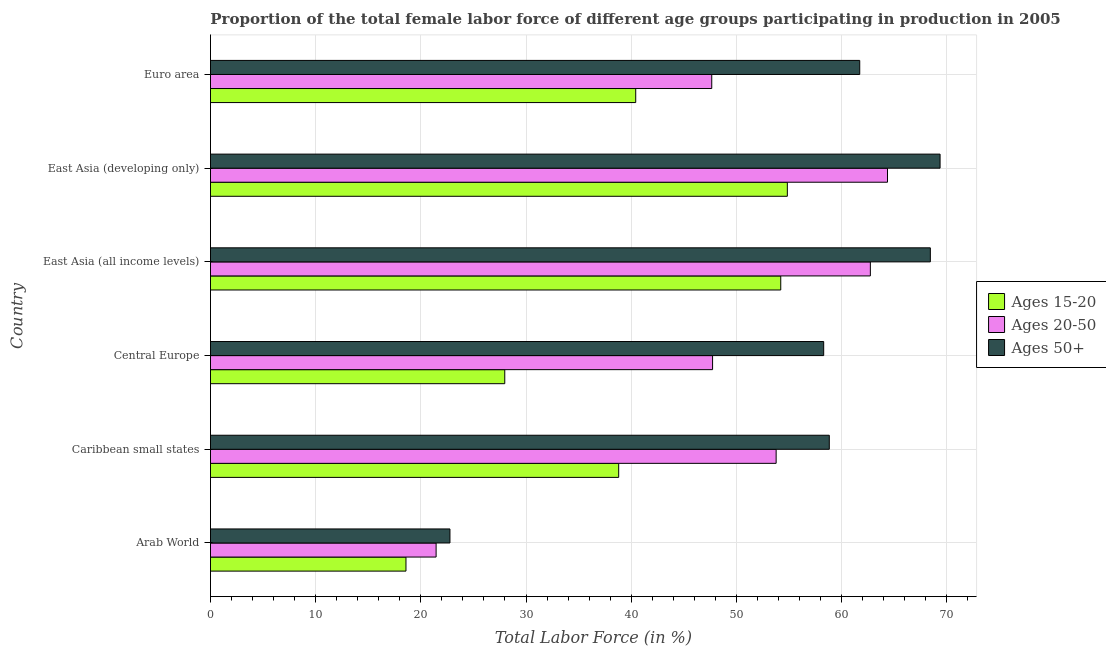How many different coloured bars are there?
Make the answer very short. 3. Are the number of bars per tick equal to the number of legend labels?
Make the answer very short. Yes. What is the label of the 5th group of bars from the top?
Give a very brief answer. Caribbean small states. In how many cases, is the number of bars for a given country not equal to the number of legend labels?
Your response must be concise. 0. What is the percentage of female labor force within the age group 15-20 in Caribbean small states?
Offer a very short reply. 38.81. Across all countries, what is the maximum percentage of female labor force above age 50?
Offer a very short reply. 69.37. Across all countries, what is the minimum percentage of female labor force within the age group 20-50?
Your answer should be compact. 21.45. In which country was the percentage of female labor force above age 50 maximum?
Make the answer very short. East Asia (developing only). In which country was the percentage of female labor force within the age group 15-20 minimum?
Your response must be concise. Arab World. What is the total percentage of female labor force within the age group 15-20 in the graph?
Make the answer very short. 234.87. What is the difference between the percentage of female labor force within the age group 20-50 in Caribbean small states and that in East Asia (all income levels)?
Provide a succinct answer. -8.96. What is the difference between the percentage of female labor force above age 50 in Central Europe and the percentage of female labor force within the age group 15-20 in Euro area?
Keep it short and to the point. 17.87. What is the average percentage of female labor force above age 50 per country?
Give a very brief answer. 56.57. What is the difference between the percentage of female labor force within the age group 20-50 and percentage of female labor force above age 50 in Arab World?
Provide a succinct answer. -1.32. What is the ratio of the percentage of female labor force within the age group 15-20 in Arab World to that in Caribbean small states?
Offer a very short reply. 0.48. Is the difference between the percentage of female labor force above age 50 in Arab World and Euro area greater than the difference between the percentage of female labor force within the age group 20-50 in Arab World and Euro area?
Offer a terse response. No. What is the difference between the highest and the second highest percentage of female labor force within the age group 15-20?
Ensure brevity in your answer.  0.63. What is the difference between the highest and the lowest percentage of female labor force above age 50?
Provide a succinct answer. 46.6. In how many countries, is the percentage of female labor force within the age group 20-50 greater than the average percentage of female labor force within the age group 20-50 taken over all countries?
Give a very brief answer. 3. What does the 3rd bar from the top in Arab World represents?
Your answer should be compact. Ages 15-20. What does the 1st bar from the bottom in Central Europe represents?
Keep it short and to the point. Ages 15-20. How many countries are there in the graph?
Offer a terse response. 6. Are the values on the major ticks of X-axis written in scientific E-notation?
Offer a very short reply. No. Does the graph contain grids?
Give a very brief answer. Yes. Where does the legend appear in the graph?
Your answer should be compact. Center right. How many legend labels are there?
Provide a succinct answer. 3. How are the legend labels stacked?
Your answer should be very brief. Vertical. What is the title of the graph?
Offer a terse response. Proportion of the total female labor force of different age groups participating in production in 2005. Does "Primary" appear as one of the legend labels in the graph?
Your response must be concise. No. What is the label or title of the X-axis?
Your answer should be very brief. Total Labor Force (in %). What is the Total Labor Force (in %) in Ages 15-20 in Arab World?
Ensure brevity in your answer.  18.59. What is the Total Labor Force (in %) of Ages 20-50 in Arab World?
Your answer should be very brief. 21.45. What is the Total Labor Force (in %) in Ages 50+ in Arab World?
Make the answer very short. 22.77. What is the Total Labor Force (in %) in Ages 15-20 in Caribbean small states?
Make the answer very short. 38.81. What is the Total Labor Force (in %) of Ages 20-50 in Caribbean small states?
Your answer should be very brief. 53.78. What is the Total Labor Force (in %) of Ages 50+ in Caribbean small states?
Your answer should be compact. 58.84. What is the Total Labor Force (in %) of Ages 15-20 in Central Europe?
Offer a very short reply. 27.98. What is the Total Labor Force (in %) in Ages 20-50 in Central Europe?
Your response must be concise. 47.74. What is the Total Labor Force (in %) in Ages 50+ in Central Europe?
Ensure brevity in your answer.  58.3. What is the Total Labor Force (in %) in Ages 15-20 in East Asia (all income levels)?
Your answer should be compact. 54.22. What is the Total Labor Force (in %) of Ages 20-50 in East Asia (all income levels)?
Your answer should be very brief. 62.74. What is the Total Labor Force (in %) in Ages 50+ in East Asia (all income levels)?
Offer a very short reply. 68.44. What is the Total Labor Force (in %) in Ages 15-20 in East Asia (developing only)?
Your answer should be very brief. 54.85. What is the Total Labor Force (in %) in Ages 20-50 in East Asia (developing only)?
Give a very brief answer. 64.37. What is the Total Labor Force (in %) of Ages 50+ in East Asia (developing only)?
Give a very brief answer. 69.37. What is the Total Labor Force (in %) of Ages 15-20 in Euro area?
Your response must be concise. 40.43. What is the Total Labor Force (in %) in Ages 20-50 in Euro area?
Your answer should be compact. 47.66. What is the Total Labor Force (in %) of Ages 50+ in Euro area?
Make the answer very short. 61.73. Across all countries, what is the maximum Total Labor Force (in %) in Ages 15-20?
Offer a very short reply. 54.85. Across all countries, what is the maximum Total Labor Force (in %) in Ages 20-50?
Offer a terse response. 64.37. Across all countries, what is the maximum Total Labor Force (in %) in Ages 50+?
Ensure brevity in your answer.  69.37. Across all countries, what is the minimum Total Labor Force (in %) in Ages 15-20?
Offer a terse response. 18.59. Across all countries, what is the minimum Total Labor Force (in %) in Ages 20-50?
Keep it short and to the point. 21.45. Across all countries, what is the minimum Total Labor Force (in %) of Ages 50+?
Give a very brief answer. 22.77. What is the total Total Labor Force (in %) of Ages 15-20 in the graph?
Ensure brevity in your answer.  234.87. What is the total Total Labor Force (in %) in Ages 20-50 in the graph?
Give a very brief answer. 297.74. What is the total Total Labor Force (in %) of Ages 50+ in the graph?
Give a very brief answer. 339.44. What is the difference between the Total Labor Force (in %) of Ages 15-20 in Arab World and that in Caribbean small states?
Ensure brevity in your answer.  -20.22. What is the difference between the Total Labor Force (in %) in Ages 20-50 in Arab World and that in Caribbean small states?
Give a very brief answer. -32.33. What is the difference between the Total Labor Force (in %) of Ages 50+ in Arab World and that in Caribbean small states?
Provide a succinct answer. -36.07. What is the difference between the Total Labor Force (in %) of Ages 15-20 in Arab World and that in Central Europe?
Make the answer very short. -9.39. What is the difference between the Total Labor Force (in %) of Ages 20-50 in Arab World and that in Central Europe?
Offer a terse response. -26.29. What is the difference between the Total Labor Force (in %) of Ages 50+ in Arab World and that in Central Europe?
Give a very brief answer. -35.53. What is the difference between the Total Labor Force (in %) of Ages 15-20 in Arab World and that in East Asia (all income levels)?
Provide a succinct answer. -35.63. What is the difference between the Total Labor Force (in %) of Ages 20-50 in Arab World and that in East Asia (all income levels)?
Your answer should be compact. -41.29. What is the difference between the Total Labor Force (in %) in Ages 50+ in Arab World and that in East Asia (all income levels)?
Ensure brevity in your answer.  -45.67. What is the difference between the Total Labor Force (in %) of Ages 15-20 in Arab World and that in East Asia (developing only)?
Offer a very short reply. -36.26. What is the difference between the Total Labor Force (in %) in Ages 20-50 in Arab World and that in East Asia (developing only)?
Offer a terse response. -42.92. What is the difference between the Total Labor Force (in %) in Ages 50+ in Arab World and that in East Asia (developing only)?
Your answer should be compact. -46.6. What is the difference between the Total Labor Force (in %) in Ages 15-20 in Arab World and that in Euro area?
Provide a succinct answer. -21.84. What is the difference between the Total Labor Force (in %) in Ages 20-50 in Arab World and that in Euro area?
Provide a succinct answer. -26.21. What is the difference between the Total Labor Force (in %) in Ages 50+ in Arab World and that in Euro area?
Provide a short and direct response. -38.96. What is the difference between the Total Labor Force (in %) of Ages 15-20 in Caribbean small states and that in Central Europe?
Keep it short and to the point. 10.83. What is the difference between the Total Labor Force (in %) in Ages 20-50 in Caribbean small states and that in Central Europe?
Offer a very short reply. 6.04. What is the difference between the Total Labor Force (in %) of Ages 50+ in Caribbean small states and that in Central Europe?
Provide a succinct answer. 0.53. What is the difference between the Total Labor Force (in %) in Ages 15-20 in Caribbean small states and that in East Asia (all income levels)?
Make the answer very short. -15.41. What is the difference between the Total Labor Force (in %) in Ages 20-50 in Caribbean small states and that in East Asia (all income levels)?
Ensure brevity in your answer.  -8.96. What is the difference between the Total Labor Force (in %) of Ages 50+ in Caribbean small states and that in East Asia (all income levels)?
Your response must be concise. -9.61. What is the difference between the Total Labor Force (in %) in Ages 15-20 in Caribbean small states and that in East Asia (developing only)?
Ensure brevity in your answer.  -16.04. What is the difference between the Total Labor Force (in %) in Ages 20-50 in Caribbean small states and that in East Asia (developing only)?
Keep it short and to the point. -10.59. What is the difference between the Total Labor Force (in %) of Ages 50+ in Caribbean small states and that in East Asia (developing only)?
Your answer should be very brief. -10.53. What is the difference between the Total Labor Force (in %) of Ages 15-20 in Caribbean small states and that in Euro area?
Keep it short and to the point. -1.62. What is the difference between the Total Labor Force (in %) in Ages 20-50 in Caribbean small states and that in Euro area?
Give a very brief answer. 6.12. What is the difference between the Total Labor Force (in %) in Ages 50+ in Caribbean small states and that in Euro area?
Your answer should be very brief. -2.89. What is the difference between the Total Labor Force (in %) of Ages 15-20 in Central Europe and that in East Asia (all income levels)?
Make the answer very short. -26.24. What is the difference between the Total Labor Force (in %) of Ages 20-50 in Central Europe and that in East Asia (all income levels)?
Offer a very short reply. -15. What is the difference between the Total Labor Force (in %) of Ages 50+ in Central Europe and that in East Asia (all income levels)?
Your answer should be compact. -10.14. What is the difference between the Total Labor Force (in %) in Ages 15-20 in Central Europe and that in East Asia (developing only)?
Provide a short and direct response. -26.87. What is the difference between the Total Labor Force (in %) of Ages 20-50 in Central Europe and that in East Asia (developing only)?
Offer a terse response. -16.63. What is the difference between the Total Labor Force (in %) in Ages 50+ in Central Europe and that in East Asia (developing only)?
Give a very brief answer. -11.07. What is the difference between the Total Labor Force (in %) of Ages 15-20 in Central Europe and that in Euro area?
Provide a succinct answer. -12.45. What is the difference between the Total Labor Force (in %) of Ages 20-50 in Central Europe and that in Euro area?
Your response must be concise. 0.08. What is the difference between the Total Labor Force (in %) of Ages 50+ in Central Europe and that in Euro area?
Offer a very short reply. -3.43. What is the difference between the Total Labor Force (in %) in Ages 15-20 in East Asia (all income levels) and that in East Asia (developing only)?
Your answer should be very brief. -0.63. What is the difference between the Total Labor Force (in %) of Ages 20-50 in East Asia (all income levels) and that in East Asia (developing only)?
Your answer should be compact. -1.63. What is the difference between the Total Labor Force (in %) of Ages 50+ in East Asia (all income levels) and that in East Asia (developing only)?
Give a very brief answer. -0.93. What is the difference between the Total Labor Force (in %) of Ages 15-20 in East Asia (all income levels) and that in Euro area?
Your response must be concise. 13.79. What is the difference between the Total Labor Force (in %) in Ages 20-50 in East Asia (all income levels) and that in Euro area?
Offer a terse response. 15.08. What is the difference between the Total Labor Force (in %) in Ages 50+ in East Asia (all income levels) and that in Euro area?
Give a very brief answer. 6.71. What is the difference between the Total Labor Force (in %) in Ages 15-20 in East Asia (developing only) and that in Euro area?
Offer a terse response. 14.42. What is the difference between the Total Labor Force (in %) in Ages 20-50 in East Asia (developing only) and that in Euro area?
Keep it short and to the point. 16.71. What is the difference between the Total Labor Force (in %) in Ages 50+ in East Asia (developing only) and that in Euro area?
Offer a very short reply. 7.64. What is the difference between the Total Labor Force (in %) in Ages 15-20 in Arab World and the Total Labor Force (in %) in Ages 20-50 in Caribbean small states?
Provide a short and direct response. -35.19. What is the difference between the Total Labor Force (in %) of Ages 15-20 in Arab World and the Total Labor Force (in %) of Ages 50+ in Caribbean small states?
Your answer should be very brief. -40.25. What is the difference between the Total Labor Force (in %) of Ages 20-50 in Arab World and the Total Labor Force (in %) of Ages 50+ in Caribbean small states?
Your answer should be compact. -37.38. What is the difference between the Total Labor Force (in %) in Ages 15-20 in Arab World and the Total Labor Force (in %) in Ages 20-50 in Central Europe?
Your answer should be compact. -29.15. What is the difference between the Total Labor Force (in %) of Ages 15-20 in Arab World and the Total Labor Force (in %) of Ages 50+ in Central Europe?
Provide a succinct answer. -39.72. What is the difference between the Total Labor Force (in %) of Ages 20-50 in Arab World and the Total Labor Force (in %) of Ages 50+ in Central Europe?
Your answer should be very brief. -36.85. What is the difference between the Total Labor Force (in %) in Ages 15-20 in Arab World and the Total Labor Force (in %) in Ages 20-50 in East Asia (all income levels)?
Make the answer very short. -44.15. What is the difference between the Total Labor Force (in %) of Ages 15-20 in Arab World and the Total Labor Force (in %) of Ages 50+ in East Asia (all income levels)?
Your answer should be very brief. -49.85. What is the difference between the Total Labor Force (in %) in Ages 20-50 in Arab World and the Total Labor Force (in %) in Ages 50+ in East Asia (all income levels)?
Your response must be concise. -46.99. What is the difference between the Total Labor Force (in %) in Ages 15-20 in Arab World and the Total Labor Force (in %) in Ages 20-50 in East Asia (developing only)?
Your answer should be very brief. -45.78. What is the difference between the Total Labor Force (in %) in Ages 15-20 in Arab World and the Total Labor Force (in %) in Ages 50+ in East Asia (developing only)?
Your response must be concise. -50.78. What is the difference between the Total Labor Force (in %) of Ages 20-50 in Arab World and the Total Labor Force (in %) of Ages 50+ in East Asia (developing only)?
Ensure brevity in your answer.  -47.91. What is the difference between the Total Labor Force (in %) of Ages 15-20 in Arab World and the Total Labor Force (in %) of Ages 20-50 in Euro area?
Your answer should be very brief. -29.07. What is the difference between the Total Labor Force (in %) in Ages 15-20 in Arab World and the Total Labor Force (in %) in Ages 50+ in Euro area?
Provide a short and direct response. -43.14. What is the difference between the Total Labor Force (in %) in Ages 20-50 in Arab World and the Total Labor Force (in %) in Ages 50+ in Euro area?
Ensure brevity in your answer.  -40.28. What is the difference between the Total Labor Force (in %) of Ages 15-20 in Caribbean small states and the Total Labor Force (in %) of Ages 20-50 in Central Europe?
Offer a very short reply. -8.93. What is the difference between the Total Labor Force (in %) in Ages 15-20 in Caribbean small states and the Total Labor Force (in %) in Ages 50+ in Central Europe?
Provide a short and direct response. -19.49. What is the difference between the Total Labor Force (in %) in Ages 20-50 in Caribbean small states and the Total Labor Force (in %) in Ages 50+ in Central Europe?
Your answer should be compact. -4.52. What is the difference between the Total Labor Force (in %) of Ages 15-20 in Caribbean small states and the Total Labor Force (in %) of Ages 20-50 in East Asia (all income levels)?
Provide a short and direct response. -23.93. What is the difference between the Total Labor Force (in %) of Ages 15-20 in Caribbean small states and the Total Labor Force (in %) of Ages 50+ in East Asia (all income levels)?
Ensure brevity in your answer.  -29.63. What is the difference between the Total Labor Force (in %) of Ages 20-50 in Caribbean small states and the Total Labor Force (in %) of Ages 50+ in East Asia (all income levels)?
Your answer should be very brief. -14.66. What is the difference between the Total Labor Force (in %) in Ages 15-20 in Caribbean small states and the Total Labor Force (in %) in Ages 20-50 in East Asia (developing only)?
Your response must be concise. -25.56. What is the difference between the Total Labor Force (in %) in Ages 15-20 in Caribbean small states and the Total Labor Force (in %) in Ages 50+ in East Asia (developing only)?
Make the answer very short. -30.56. What is the difference between the Total Labor Force (in %) of Ages 20-50 in Caribbean small states and the Total Labor Force (in %) of Ages 50+ in East Asia (developing only)?
Provide a short and direct response. -15.59. What is the difference between the Total Labor Force (in %) of Ages 15-20 in Caribbean small states and the Total Labor Force (in %) of Ages 20-50 in Euro area?
Keep it short and to the point. -8.85. What is the difference between the Total Labor Force (in %) of Ages 15-20 in Caribbean small states and the Total Labor Force (in %) of Ages 50+ in Euro area?
Give a very brief answer. -22.92. What is the difference between the Total Labor Force (in %) in Ages 20-50 in Caribbean small states and the Total Labor Force (in %) in Ages 50+ in Euro area?
Offer a terse response. -7.95. What is the difference between the Total Labor Force (in %) of Ages 15-20 in Central Europe and the Total Labor Force (in %) of Ages 20-50 in East Asia (all income levels)?
Keep it short and to the point. -34.76. What is the difference between the Total Labor Force (in %) in Ages 15-20 in Central Europe and the Total Labor Force (in %) in Ages 50+ in East Asia (all income levels)?
Make the answer very short. -40.46. What is the difference between the Total Labor Force (in %) in Ages 20-50 in Central Europe and the Total Labor Force (in %) in Ages 50+ in East Asia (all income levels)?
Your answer should be very brief. -20.7. What is the difference between the Total Labor Force (in %) of Ages 15-20 in Central Europe and the Total Labor Force (in %) of Ages 20-50 in East Asia (developing only)?
Provide a succinct answer. -36.39. What is the difference between the Total Labor Force (in %) in Ages 15-20 in Central Europe and the Total Labor Force (in %) in Ages 50+ in East Asia (developing only)?
Provide a short and direct response. -41.39. What is the difference between the Total Labor Force (in %) in Ages 20-50 in Central Europe and the Total Labor Force (in %) in Ages 50+ in East Asia (developing only)?
Your answer should be compact. -21.63. What is the difference between the Total Labor Force (in %) in Ages 15-20 in Central Europe and the Total Labor Force (in %) in Ages 20-50 in Euro area?
Provide a short and direct response. -19.68. What is the difference between the Total Labor Force (in %) in Ages 15-20 in Central Europe and the Total Labor Force (in %) in Ages 50+ in Euro area?
Provide a short and direct response. -33.75. What is the difference between the Total Labor Force (in %) of Ages 20-50 in Central Europe and the Total Labor Force (in %) of Ages 50+ in Euro area?
Make the answer very short. -13.99. What is the difference between the Total Labor Force (in %) of Ages 15-20 in East Asia (all income levels) and the Total Labor Force (in %) of Ages 20-50 in East Asia (developing only)?
Your answer should be very brief. -10.15. What is the difference between the Total Labor Force (in %) of Ages 15-20 in East Asia (all income levels) and the Total Labor Force (in %) of Ages 50+ in East Asia (developing only)?
Give a very brief answer. -15.15. What is the difference between the Total Labor Force (in %) in Ages 20-50 in East Asia (all income levels) and the Total Labor Force (in %) in Ages 50+ in East Asia (developing only)?
Keep it short and to the point. -6.63. What is the difference between the Total Labor Force (in %) in Ages 15-20 in East Asia (all income levels) and the Total Labor Force (in %) in Ages 20-50 in Euro area?
Give a very brief answer. 6.56. What is the difference between the Total Labor Force (in %) of Ages 15-20 in East Asia (all income levels) and the Total Labor Force (in %) of Ages 50+ in Euro area?
Offer a terse response. -7.51. What is the difference between the Total Labor Force (in %) in Ages 20-50 in East Asia (all income levels) and the Total Labor Force (in %) in Ages 50+ in Euro area?
Offer a terse response. 1.01. What is the difference between the Total Labor Force (in %) of Ages 15-20 in East Asia (developing only) and the Total Labor Force (in %) of Ages 20-50 in Euro area?
Your answer should be very brief. 7.19. What is the difference between the Total Labor Force (in %) of Ages 15-20 in East Asia (developing only) and the Total Labor Force (in %) of Ages 50+ in Euro area?
Give a very brief answer. -6.88. What is the difference between the Total Labor Force (in %) in Ages 20-50 in East Asia (developing only) and the Total Labor Force (in %) in Ages 50+ in Euro area?
Keep it short and to the point. 2.64. What is the average Total Labor Force (in %) in Ages 15-20 per country?
Your response must be concise. 39.15. What is the average Total Labor Force (in %) of Ages 20-50 per country?
Your answer should be compact. 49.62. What is the average Total Labor Force (in %) of Ages 50+ per country?
Keep it short and to the point. 56.57. What is the difference between the Total Labor Force (in %) of Ages 15-20 and Total Labor Force (in %) of Ages 20-50 in Arab World?
Your response must be concise. -2.87. What is the difference between the Total Labor Force (in %) of Ages 15-20 and Total Labor Force (in %) of Ages 50+ in Arab World?
Your answer should be compact. -4.18. What is the difference between the Total Labor Force (in %) of Ages 20-50 and Total Labor Force (in %) of Ages 50+ in Arab World?
Make the answer very short. -1.32. What is the difference between the Total Labor Force (in %) in Ages 15-20 and Total Labor Force (in %) in Ages 20-50 in Caribbean small states?
Your answer should be very brief. -14.97. What is the difference between the Total Labor Force (in %) of Ages 15-20 and Total Labor Force (in %) of Ages 50+ in Caribbean small states?
Make the answer very short. -20.02. What is the difference between the Total Labor Force (in %) in Ages 20-50 and Total Labor Force (in %) in Ages 50+ in Caribbean small states?
Ensure brevity in your answer.  -5.05. What is the difference between the Total Labor Force (in %) of Ages 15-20 and Total Labor Force (in %) of Ages 20-50 in Central Europe?
Offer a very short reply. -19.76. What is the difference between the Total Labor Force (in %) in Ages 15-20 and Total Labor Force (in %) in Ages 50+ in Central Europe?
Offer a very short reply. -30.32. What is the difference between the Total Labor Force (in %) in Ages 20-50 and Total Labor Force (in %) in Ages 50+ in Central Europe?
Give a very brief answer. -10.56. What is the difference between the Total Labor Force (in %) of Ages 15-20 and Total Labor Force (in %) of Ages 20-50 in East Asia (all income levels)?
Ensure brevity in your answer.  -8.52. What is the difference between the Total Labor Force (in %) of Ages 15-20 and Total Labor Force (in %) of Ages 50+ in East Asia (all income levels)?
Give a very brief answer. -14.22. What is the difference between the Total Labor Force (in %) in Ages 20-50 and Total Labor Force (in %) in Ages 50+ in East Asia (all income levels)?
Make the answer very short. -5.7. What is the difference between the Total Labor Force (in %) in Ages 15-20 and Total Labor Force (in %) in Ages 20-50 in East Asia (developing only)?
Your answer should be compact. -9.52. What is the difference between the Total Labor Force (in %) of Ages 15-20 and Total Labor Force (in %) of Ages 50+ in East Asia (developing only)?
Offer a very short reply. -14.52. What is the difference between the Total Labor Force (in %) in Ages 20-50 and Total Labor Force (in %) in Ages 50+ in East Asia (developing only)?
Ensure brevity in your answer.  -5. What is the difference between the Total Labor Force (in %) in Ages 15-20 and Total Labor Force (in %) in Ages 20-50 in Euro area?
Give a very brief answer. -7.23. What is the difference between the Total Labor Force (in %) in Ages 15-20 and Total Labor Force (in %) in Ages 50+ in Euro area?
Your response must be concise. -21.3. What is the difference between the Total Labor Force (in %) of Ages 20-50 and Total Labor Force (in %) of Ages 50+ in Euro area?
Offer a very short reply. -14.07. What is the ratio of the Total Labor Force (in %) of Ages 15-20 in Arab World to that in Caribbean small states?
Provide a succinct answer. 0.48. What is the ratio of the Total Labor Force (in %) of Ages 20-50 in Arab World to that in Caribbean small states?
Your response must be concise. 0.4. What is the ratio of the Total Labor Force (in %) in Ages 50+ in Arab World to that in Caribbean small states?
Make the answer very short. 0.39. What is the ratio of the Total Labor Force (in %) of Ages 15-20 in Arab World to that in Central Europe?
Keep it short and to the point. 0.66. What is the ratio of the Total Labor Force (in %) of Ages 20-50 in Arab World to that in Central Europe?
Offer a very short reply. 0.45. What is the ratio of the Total Labor Force (in %) of Ages 50+ in Arab World to that in Central Europe?
Provide a short and direct response. 0.39. What is the ratio of the Total Labor Force (in %) of Ages 15-20 in Arab World to that in East Asia (all income levels)?
Offer a very short reply. 0.34. What is the ratio of the Total Labor Force (in %) of Ages 20-50 in Arab World to that in East Asia (all income levels)?
Your answer should be very brief. 0.34. What is the ratio of the Total Labor Force (in %) in Ages 50+ in Arab World to that in East Asia (all income levels)?
Your answer should be compact. 0.33. What is the ratio of the Total Labor Force (in %) of Ages 15-20 in Arab World to that in East Asia (developing only)?
Offer a terse response. 0.34. What is the ratio of the Total Labor Force (in %) of Ages 50+ in Arab World to that in East Asia (developing only)?
Give a very brief answer. 0.33. What is the ratio of the Total Labor Force (in %) of Ages 15-20 in Arab World to that in Euro area?
Offer a very short reply. 0.46. What is the ratio of the Total Labor Force (in %) in Ages 20-50 in Arab World to that in Euro area?
Make the answer very short. 0.45. What is the ratio of the Total Labor Force (in %) of Ages 50+ in Arab World to that in Euro area?
Provide a short and direct response. 0.37. What is the ratio of the Total Labor Force (in %) in Ages 15-20 in Caribbean small states to that in Central Europe?
Your answer should be compact. 1.39. What is the ratio of the Total Labor Force (in %) of Ages 20-50 in Caribbean small states to that in Central Europe?
Your answer should be very brief. 1.13. What is the ratio of the Total Labor Force (in %) of Ages 50+ in Caribbean small states to that in Central Europe?
Your answer should be very brief. 1.01. What is the ratio of the Total Labor Force (in %) of Ages 15-20 in Caribbean small states to that in East Asia (all income levels)?
Your answer should be compact. 0.72. What is the ratio of the Total Labor Force (in %) of Ages 20-50 in Caribbean small states to that in East Asia (all income levels)?
Your answer should be compact. 0.86. What is the ratio of the Total Labor Force (in %) of Ages 50+ in Caribbean small states to that in East Asia (all income levels)?
Give a very brief answer. 0.86. What is the ratio of the Total Labor Force (in %) of Ages 15-20 in Caribbean small states to that in East Asia (developing only)?
Make the answer very short. 0.71. What is the ratio of the Total Labor Force (in %) in Ages 20-50 in Caribbean small states to that in East Asia (developing only)?
Your response must be concise. 0.84. What is the ratio of the Total Labor Force (in %) in Ages 50+ in Caribbean small states to that in East Asia (developing only)?
Your response must be concise. 0.85. What is the ratio of the Total Labor Force (in %) of Ages 15-20 in Caribbean small states to that in Euro area?
Offer a very short reply. 0.96. What is the ratio of the Total Labor Force (in %) in Ages 20-50 in Caribbean small states to that in Euro area?
Your answer should be very brief. 1.13. What is the ratio of the Total Labor Force (in %) in Ages 50+ in Caribbean small states to that in Euro area?
Give a very brief answer. 0.95. What is the ratio of the Total Labor Force (in %) of Ages 15-20 in Central Europe to that in East Asia (all income levels)?
Offer a terse response. 0.52. What is the ratio of the Total Labor Force (in %) of Ages 20-50 in Central Europe to that in East Asia (all income levels)?
Your answer should be very brief. 0.76. What is the ratio of the Total Labor Force (in %) in Ages 50+ in Central Europe to that in East Asia (all income levels)?
Offer a terse response. 0.85. What is the ratio of the Total Labor Force (in %) in Ages 15-20 in Central Europe to that in East Asia (developing only)?
Provide a short and direct response. 0.51. What is the ratio of the Total Labor Force (in %) of Ages 20-50 in Central Europe to that in East Asia (developing only)?
Your answer should be compact. 0.74. What is the ratio of the Total Labor Force (in %) in Ages 50+ in Central Europe to that in East Asia (developing only)?
Make the answer very short. 0.84. What is the ratio of the Total Labor Force (in %) in Ages 15-20 in Central Europe to that in Euro area?
Provide a succinct answer. 0.69. What is the ratio of the Total Labor Force (in %) of Ages 20-50 in Central Europe to that in Euro area?
Provide a succinct answer. 1. What is the ratio of the Total Labor Force (in %) in Ages 50+ in Central Europe to that in Euro area?
Provide a succinct answer. 0.94. What is the ratio of the Total Labor Force (in %) of Ages 15-20 in East Asia (all income levels) to that in East Asia (developing only)?
Offer a very short reply. 0.99. What is the ratio of the Total Labor Force (in %) in Ages 20-50 in East Asia (all income levels) to that in East Asia (developing only)?
Make the answer very short. 0.97. What is the ratio of the Total Labor Force (in %) in Ages 50+ in East Asia (all income levels) to that in East Asia (developing only)?
Your response must be concise. 0.99. What is the ratio of the Total Labor Force (in %) in Ages 15-20 in East Asia (all income levels) to that in Euro area?
Offer a very short reply. 1.34. What is the ratio of the Total Labor Force (in %) in Ages 20-50 in East Asia (all income levels) to that in Euro area?
Make the answer very short. 1.32. What is the ratio of the Total Labor Force (in %) of Ages 50+ in East Asia (all income levels) to that in Euro area?
Provide a short and direct response. 1.11. What is the ratio of the Total Labor Force (in %) of Ages 15-20 in East Asia (developing only) to that in Euro area?
Provide a short and direct response. 1.36. What is the ratio of the Total Labor Force (in %) of Ages 20-50 in East Asia (developing only) to that in Euro area?
Ensure brevity in your answer.  1.35. What is the ratio of the Total Labor Force (in %) of Ages 50+ in East Asia (developing only) to that in Euro area?
Offer a terse response. 1.12. What is the difference between the highest and the second highest Total Labor Force (in %) of Ages 15-20?
Your answer should be compact. 0.63. What is the difference between the highest and the second highest Total Labor Force (in %) of Ages 20-50?
Your answer should be compact. 1.63. What is the difference between the highest and the second highest Total Labor Force (in %) of Ages 50+?
Your response must be concise. 0.93. What is the difference between the highest and the lowest Total Labor Force (in %) in Ages 15-20?
Provide a short and direct response. 36.26. What is the difference between the highest and the lowest Total Labor Force (in %) of Ages 20-50?
Offer a terse response. 42.92. What is the difference between the highest and the lowest Total Labor Force (in %) of Ages 50+?
Make the answer very short. 46.6. 